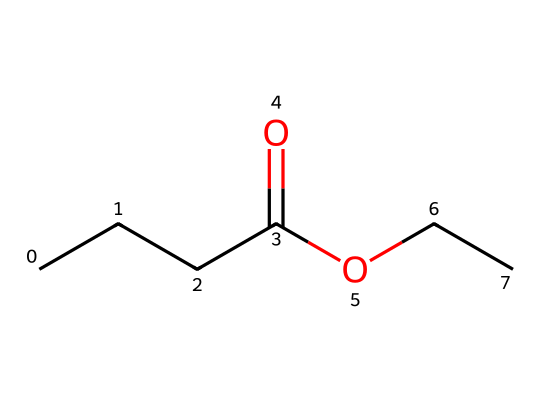What is the common name for this compound? The SMILES representation points to a compound with a butyrate group (CCCC(=O)O) connected to an ethyl group (CC), which is recognized as ethyl butyrate.
Answer: ethyl butyrate How many carbon atoms are present in the structure? Counting the carbon atoms in both the butyrate and ethyl groups, there are a total of five carbon atoms (four from the butyrate and one from the ethyl group).
Answer: five What type of functional group does ethyl butyrate contain? Ethyl butyrate includes a carboxylate functional group (due to the presence of C(=O)O), signifying it is an ester.
Answer: ester What scent is ethyl butyrate known for? This compound is renowned for its fruity scent, which is often associated with an aroma of pineapple or apple.
Answer: fruity scent Which part of the molecule is responsible for its flavor profile? The butyrate part of ethyl butyrate, linked to its ester structure, is primarily responsible for the compound's fruity flavor and scent properties.
Answer: butyrate How many oxygen atoms are in ethyl butyrate? Analyzing the structure reveals that there are two oxygen atoms in ethyl butyrate, highlighted in the functional group (C(=O)O).
Answer: two 